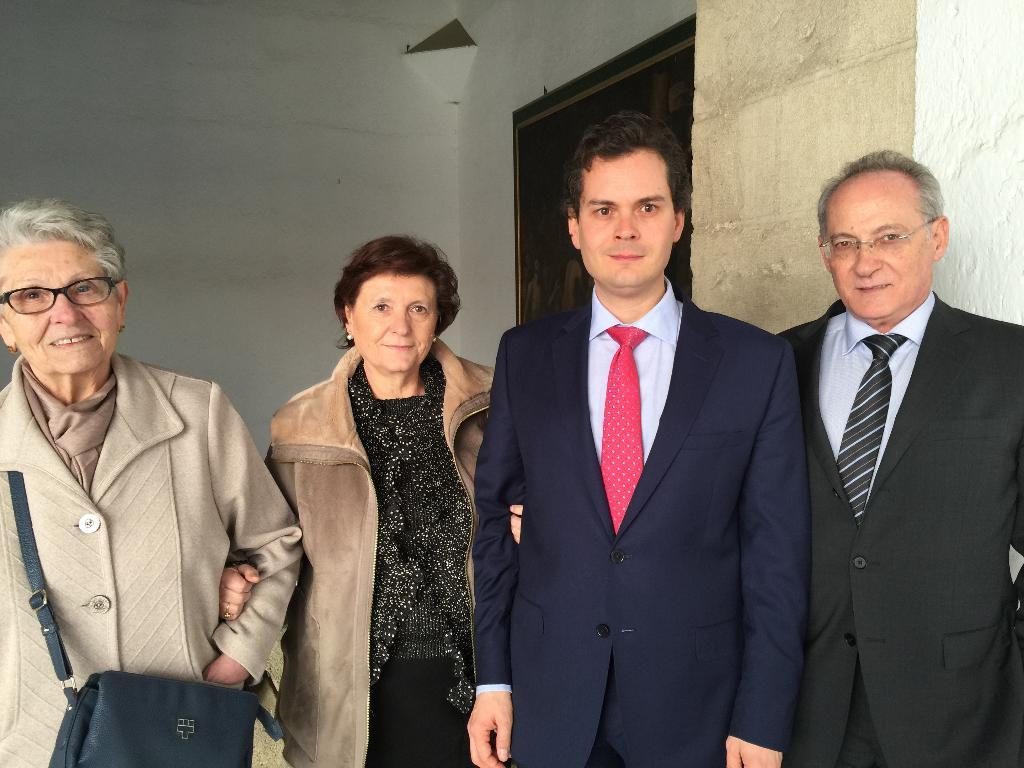How many people are in the image? There is a group of people in the image, but the exact number is not specified. What can be seen in the background of the image? There is a wall in the background of the image. What is the credit score of the person standing on the left in the image? There is no information about credit scores or individual people in the image, as it only shows a group of people and a wall in the background. 